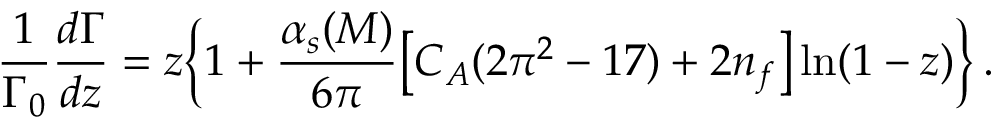<formula> <loc_0><loc_0><loc_500><loc_500>\frac { 1 } { \Gamma _ { 0 } } \frac { d \Gamma } { d z } = z \left \{ 1 + \frac { \alpha _ { s } ( M ) } { 6 \pi } \left [ C _ { A } ( 2 \pi ^ { 2 } - 1 7 ) + 2 n _ { f } \right ] \ln ( 1 - z ) \right \} \, .</formula> 